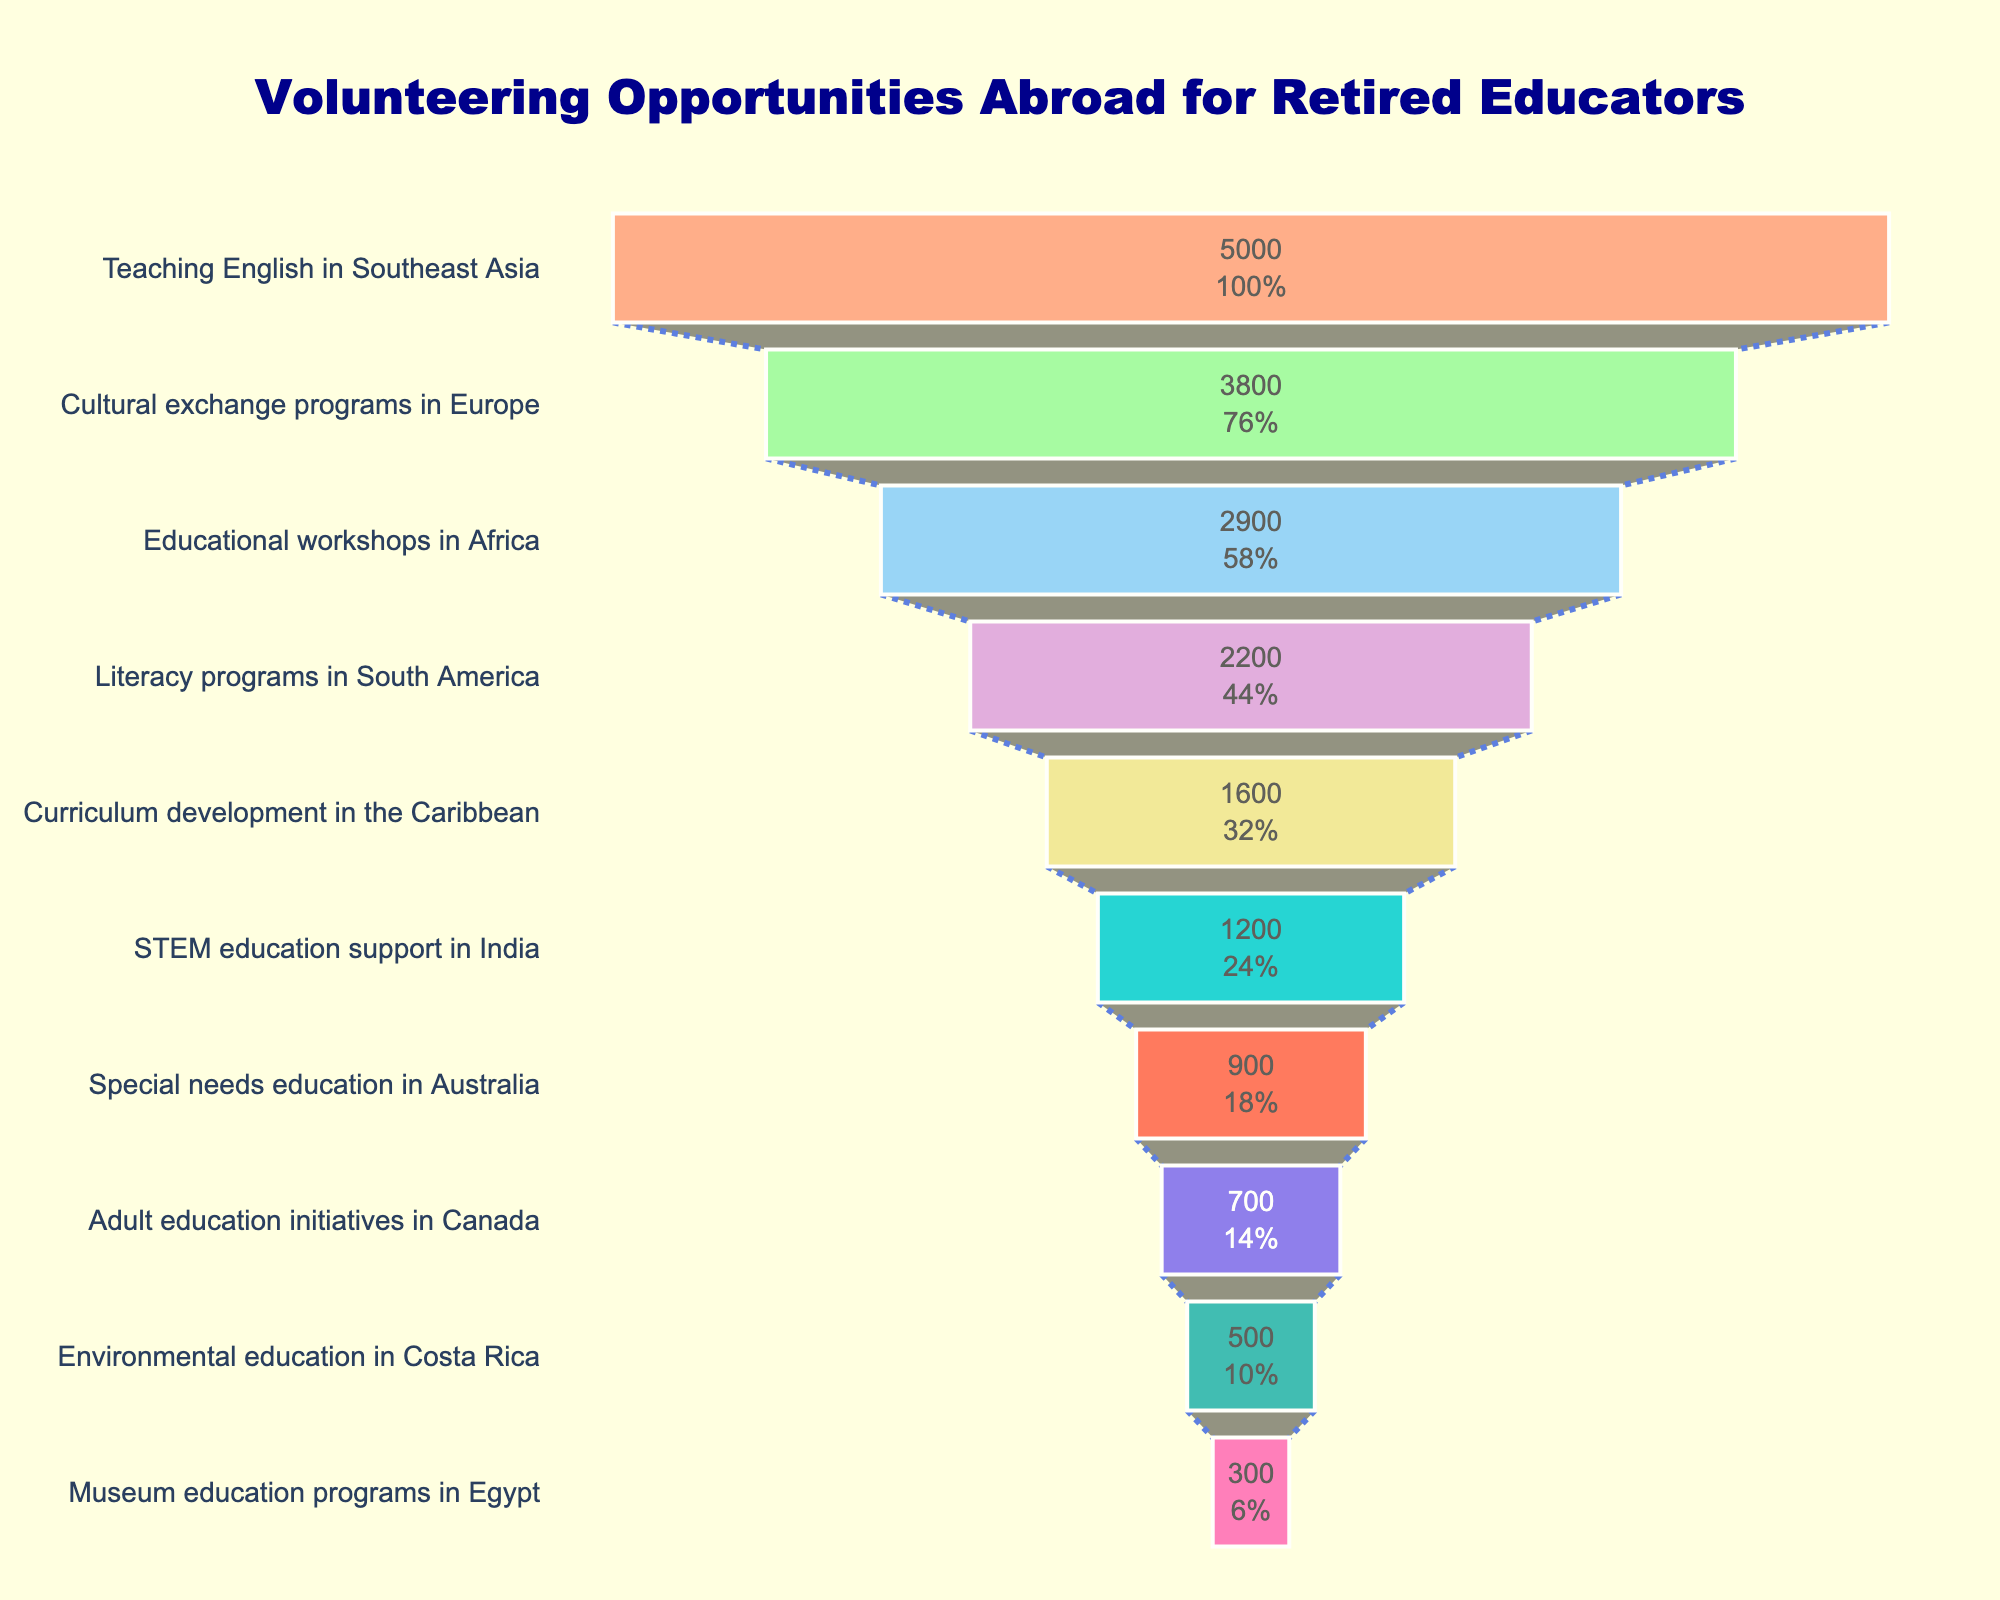What is the most popular volunteering opportunity? The top entry in the funnel chart with the highest number of participants is listed first. It is "Teaching English in Southeast Asia" with 5000 participants.
Answer: Teaching English in Southeast Asia What is the least common volunteering opportunity? The bottom entry in the funnel chart with the lowest number of participants is listed last. It is "Museum education programs in Egypt" with 300 participants.
Answer: Museum education programs in Egypt How many participants are involved in Cultural exchange programs in Europe? The funnel section labeled "Cultural exchange programs in Europe" shows the number of participants directly inside the section. It indicates there are 3800 participants.
Answer: 3800 How does the number of participants in STEM education support in India compare to Special needs education in Australia? Check the funnel sections for both "STEM education support in India" and "Special needs education in Australia". The STEM education in India has 1200 participants whereas Special needs education in Australia has 900 participants, showing STEM in India has more participants.
Answer: STEM in India has more participants What percentage of the total participants is involved in Literacy programs in South America? Firstly, sum all participants: 5000 + 3800 + 2900 + 2200 + 1600 + 1200 + 900 + 700 + 500 + 300, which equals 19,100. Then, divide the participants in Literacy programs in South America (2200) by the total participants (19,100) and multiply by 100 to get the percentage. (2200 / 19100) * 100 = approximately 11.52%.
Answer: Approximately 11.52% What are the opportunities with fewer than 1000 participants? Identify the sections of the funnel chart where the number of participants is less than 1000. These include "Special needs education in Australia" (900), "Adult education initiatives in Canada" (700), "Environmental education in Costa Rica" (500), and "Museum education programs in Egypt" (300).
Answer: Special needs education in Australia, Adult education initiatives in Canada, Environmental education in Costa Rica, Museum education programs in Egypt How many more participants are involved in Educational workshops in Africa compared to Curriculum development in the Caribbean? Subtract the number of participants in "Curriculum development in the Caribbean" (1600) from those involved in "Educational workshops in Africa" (2900). 2900 - 1600 = 1300.
Answer: 1300 Which regions are targeted by the top three most popular volunteer opportunities? The top three sections in the funnel chart represent "Teaching English in Southeast Asia," "Cultural exchange programs in Europe," and "Educational workshops in Africa." Therefore, the targeted regions are Southeast Asia, Europe, and Africa.
Answer: Southeast Asia, Europe, Africa 